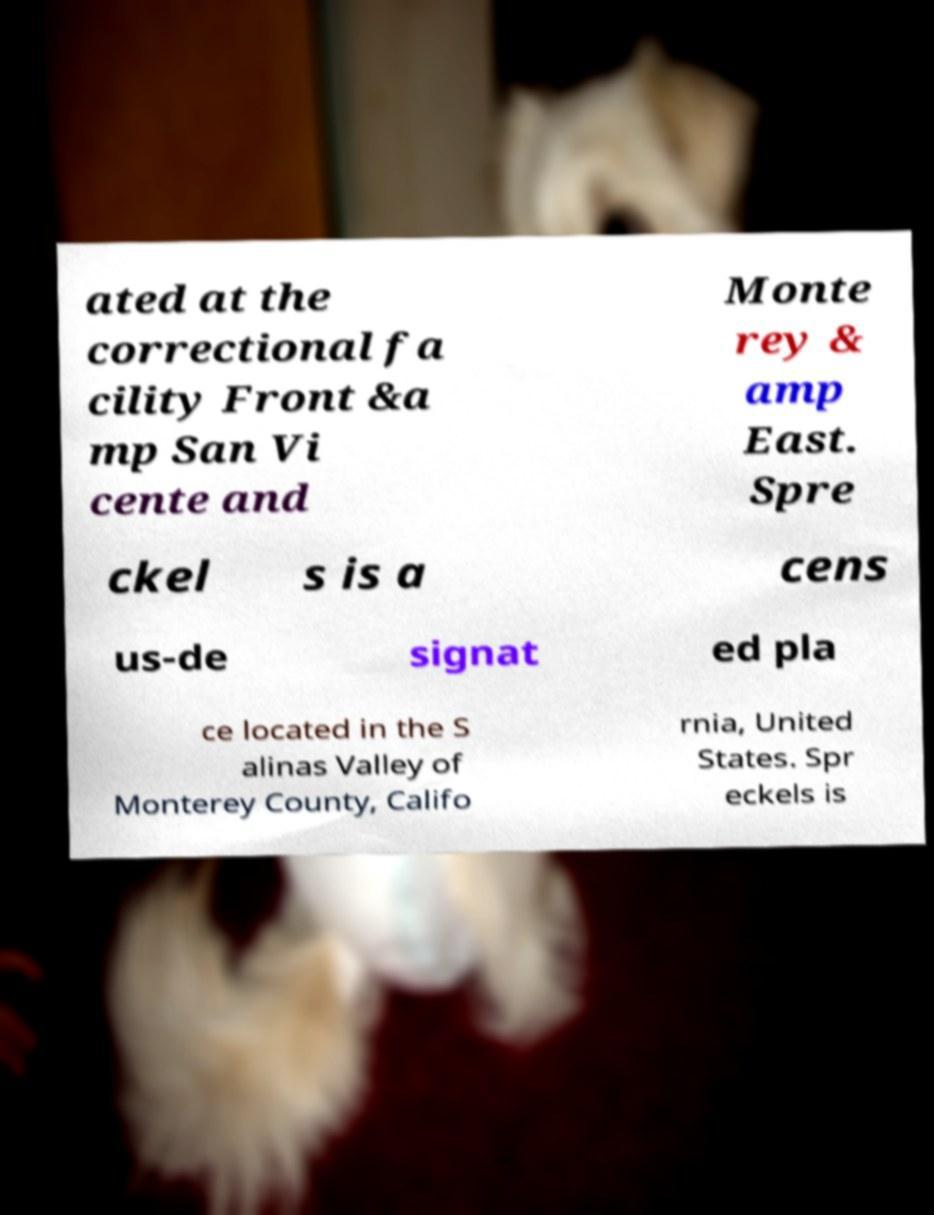What messages or text are displayed in this image? I need them in a readable, typed format. ated at the correctional fa cility Front &a mp San Vi cente and Monte rey & amp East. Spre ckel s is a cens us-de signat ed pla ce located in the S alinas Valley of Monterey County, Califo rnia, United States. Spr eckels is 